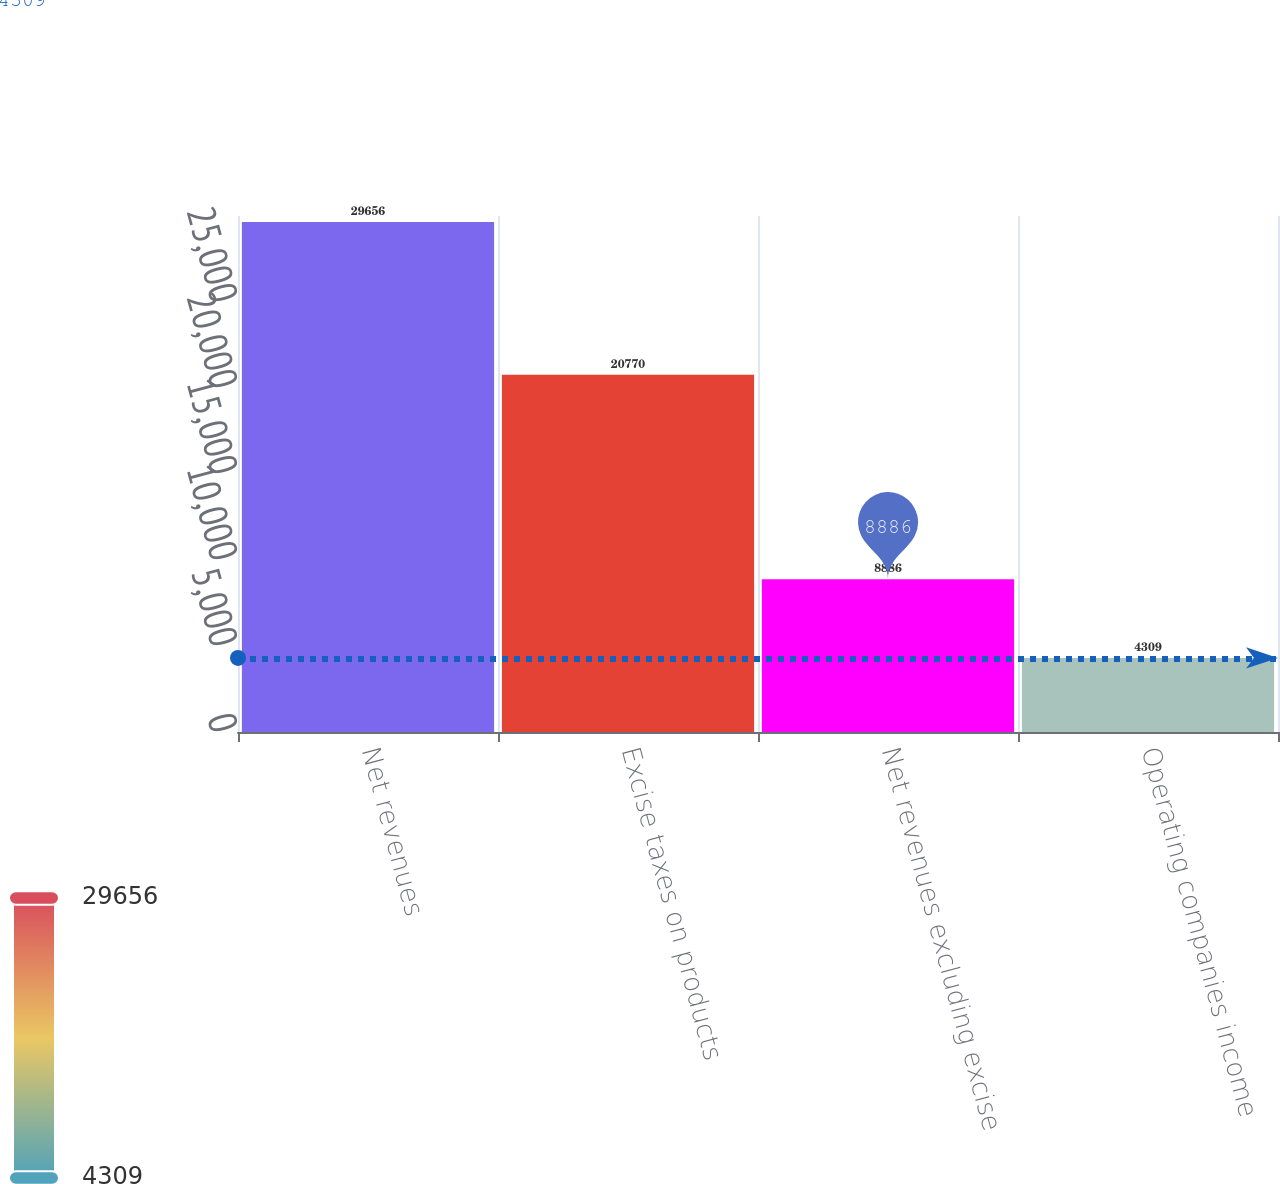Convert chart to OTSL. <chart><loc_0><loc_0><loc_500><loc_500><bar_chart><fcel>Net revenues<fcel>Excise taxes on products<fcel>Net revenues excluding excise<fcel>Operating companies income<nl><fcel>29656<fcel>20770<fcel>8886<fcel>4309<nl></chart> 